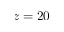<formula> <loc_0><loc_0><loc_500><loc_500>z = 2 0</formula> 